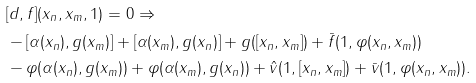Convert formula to latex. <formula><loc_0><loc_0><loc_500><loc_500>& [ d , f ] ( x _ { n } , x _ { m } , 1 ) = 0 \Rightarrow \\ & - [ \alpha ( x _ { n } ) , g ( x _ { m } ) ] + [ \alpha ( x _ { m } ) , g ( x _ { n } ) ] + g ( [ x _ { n } , x _ { m } ] ) + \bar { f } ( 1 , \varphi ( x _ { n } , x _ { m } ) ) \\ & - \varphi ( \alpha ( x _ { n } ) , g ( x _ { m } ) ) + \varphi ( \alpha ( x _ { m } ) , g ( x _ { n } ) ) + \hat { v } ( 1 , [ x _ { n } , x _ { m } ] ) + \bar { v } ( 1 , \varphi ( x _ { n } , x _ { m } ) ) .</formula> 